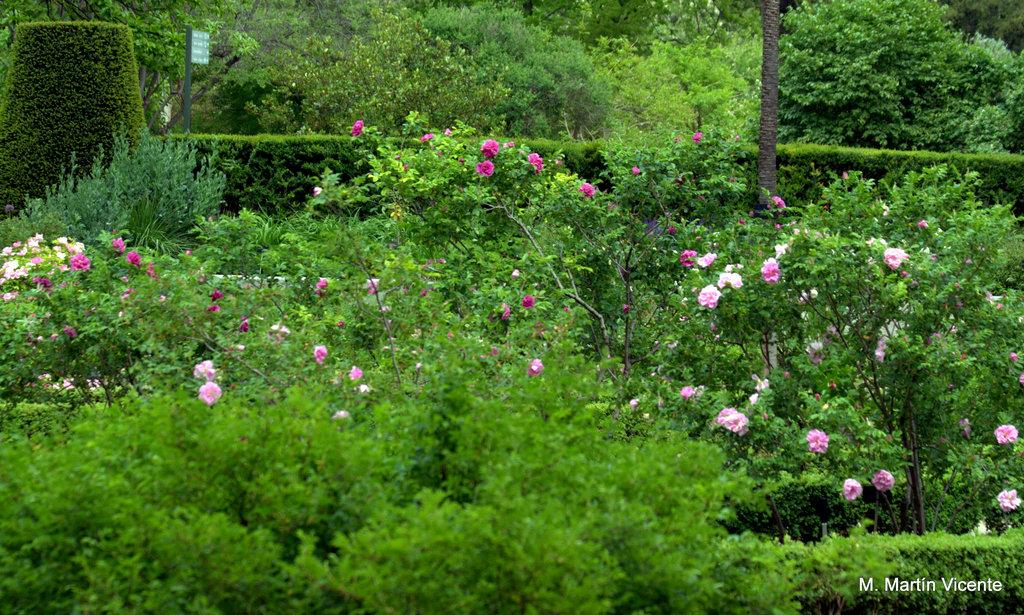What is the main subject in the center of the image? There are plants in the center of the image. What can be seen among the plants? Flowers are present among the plants. What type of vegetation is visible at the top of the image? There are trees and bushes visible at the top of the image. What is located at the top of the image? A signboard is present at the top of the image. What type of gold material is used to form the cover of the plants in the image? There is no gold material or cover present in the image; the plants are not covered. 